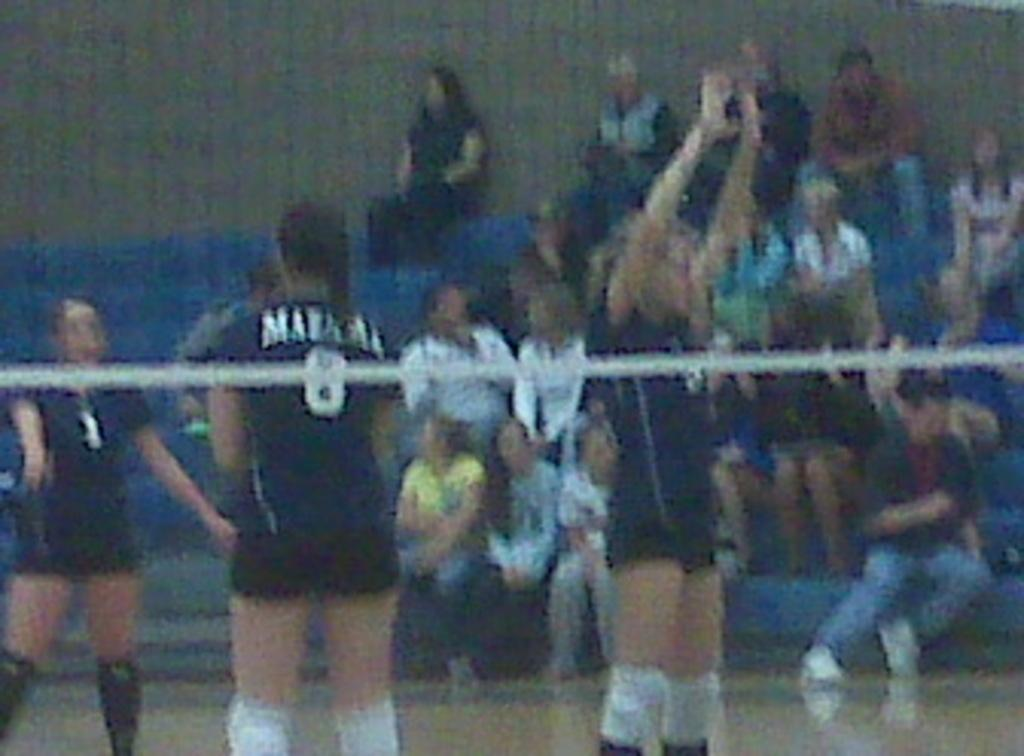Who is present in the image? There are people in the image. What are the people wearing? The people are wearing sports dress. What can be seen in the image besides the people? There is a net in the image. Are there any other people visible in the image? Yes, there are other people in the background of the image. How many sisters are playing with the mask in the image? There is no mask or sisters present in the image. What type of team is visible in the image? There is no team visible in the image; it features people wearing sports dress and a net, which suggests a sports activity, but not a team. 